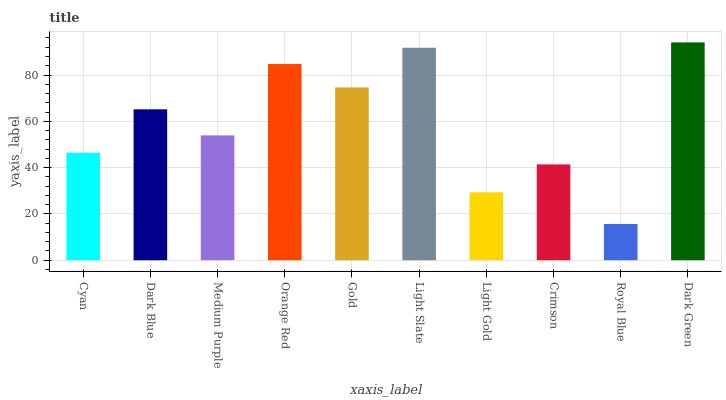Is Royal Blue the minimum?
Answer yes or no. Yes. Is Dark Green the maximum?
Answer yes or no. Yes. Is Dark Blue the minimum?
Answer yes or no. No. Is Dark Blue the maximum?
Answer yes or no. No. Is Dark Blue greater than Cyan?
Answer yes or no. Yes. Is Cyan less than Dark Blue?
Answer yes or no. Yes. Is Cyan greater than Dark Blue?
Answer yes or no. No. Is Dark Blue less than Cyan?
Answer yes or no. No. Is Dark Blue the high median?
Answer yes or no. Yes. Is Medium Purple the low median?
Answer yes or no. Yes. Is Royal Blue the high median?
Answer yes or no. No. Is Gold the low median?
Answer yes or no. No. 